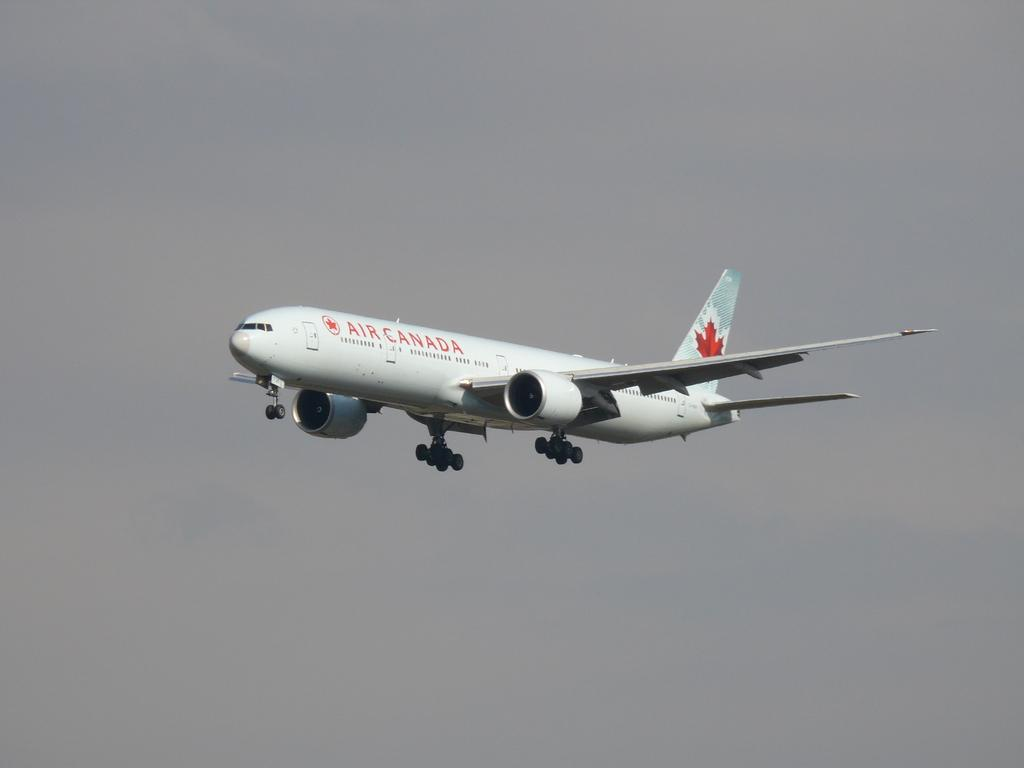Provide a one-sentence caption for the provided image. An airplane in the sky with a maple leaf from the company Air Canada. 